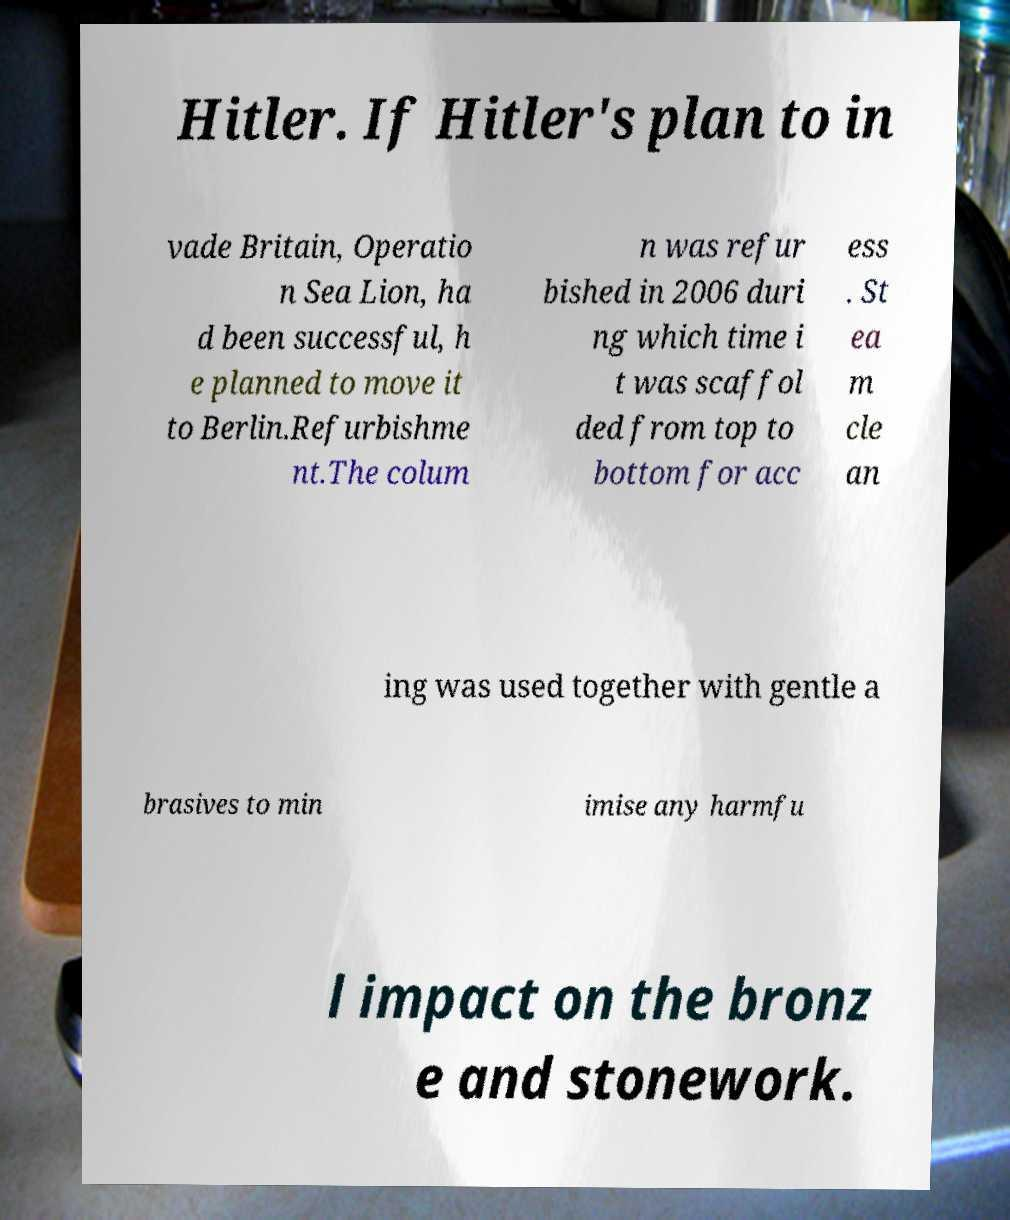Please identify and transcribe the text found in this image. Hitler. If Hitler's plan to in vade Britain, Operatio n Sea Lion, ha d been successful, h e planned to move it to Berlin.Refurbishme nt.The colum n was refur bished in 2006 duri ng which time i t was scaffol ded from top to bottom for acc ess . St ea m cle an ing was used together with gentle a brasives to min imise any harmfu l impact on the bronz e and stonework. 